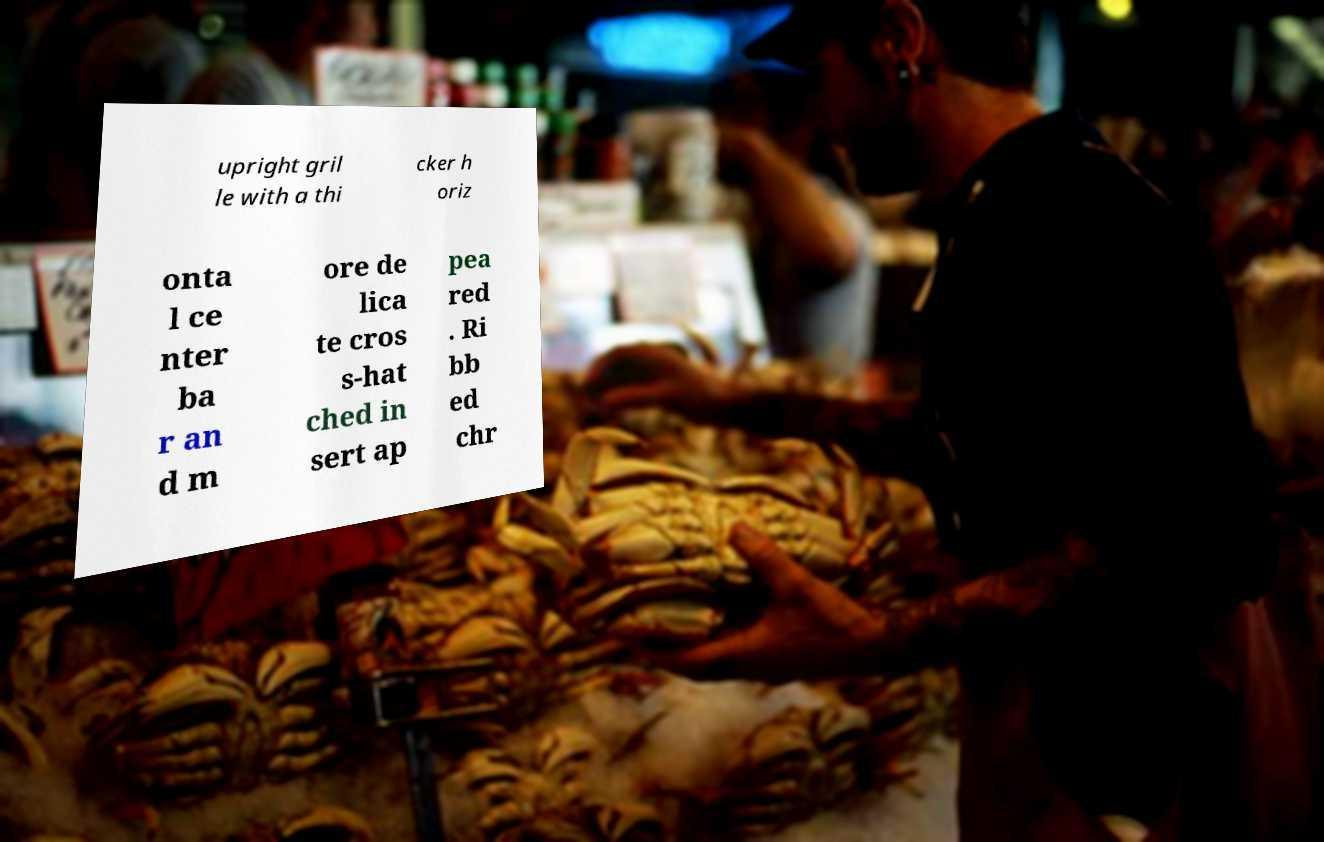What messages or text are displayed in this image? I need them in a readable, typed format. upright gril le with a thi cker h oriz onta l ce nter ba r an d m ore de lica te cros s-hat ched in sert ap pea red . Ri bb ed chr 